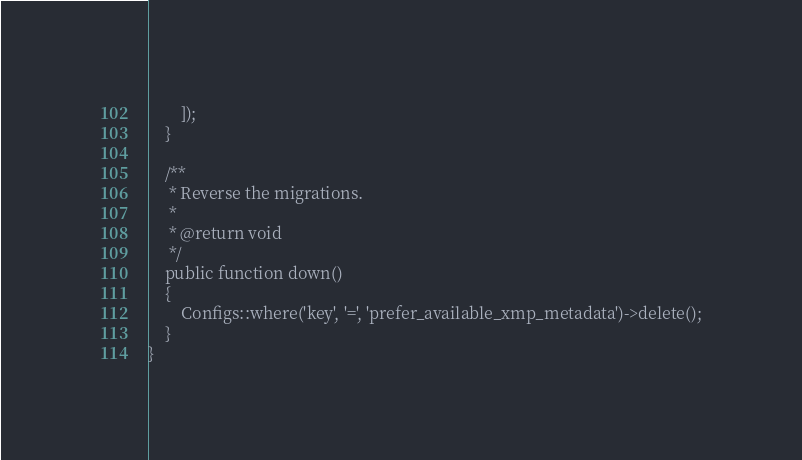<code> <loc_0><loc_0><loc_500><loc_500><_PHP_>		]);
	}

	/**
	 * Reverse the migrations.
	 *
	 * @return void
	 */
	public function down()
	{
		Configs::where('key', '=', 'prefer_available_xmp_metadata')->delete();
	}
}
</code> 